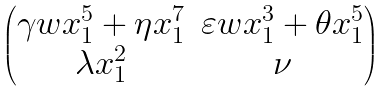Convert formula to latex. <formula><loc_0><loc_0><loc_500><loc_500>\begin{pmatrix} \gamma w x _ { 1 } ^ { 5 } + \eta x _ { 1 } ^ { 7 } & \varepsilon w x _ { 1 } ^ { 3 } + \theta x _ { 1 } ^ { 5 } \\ \lambda x _ { 1 } ^ { 2 } & \nu \end{pmatrix}</formula> 